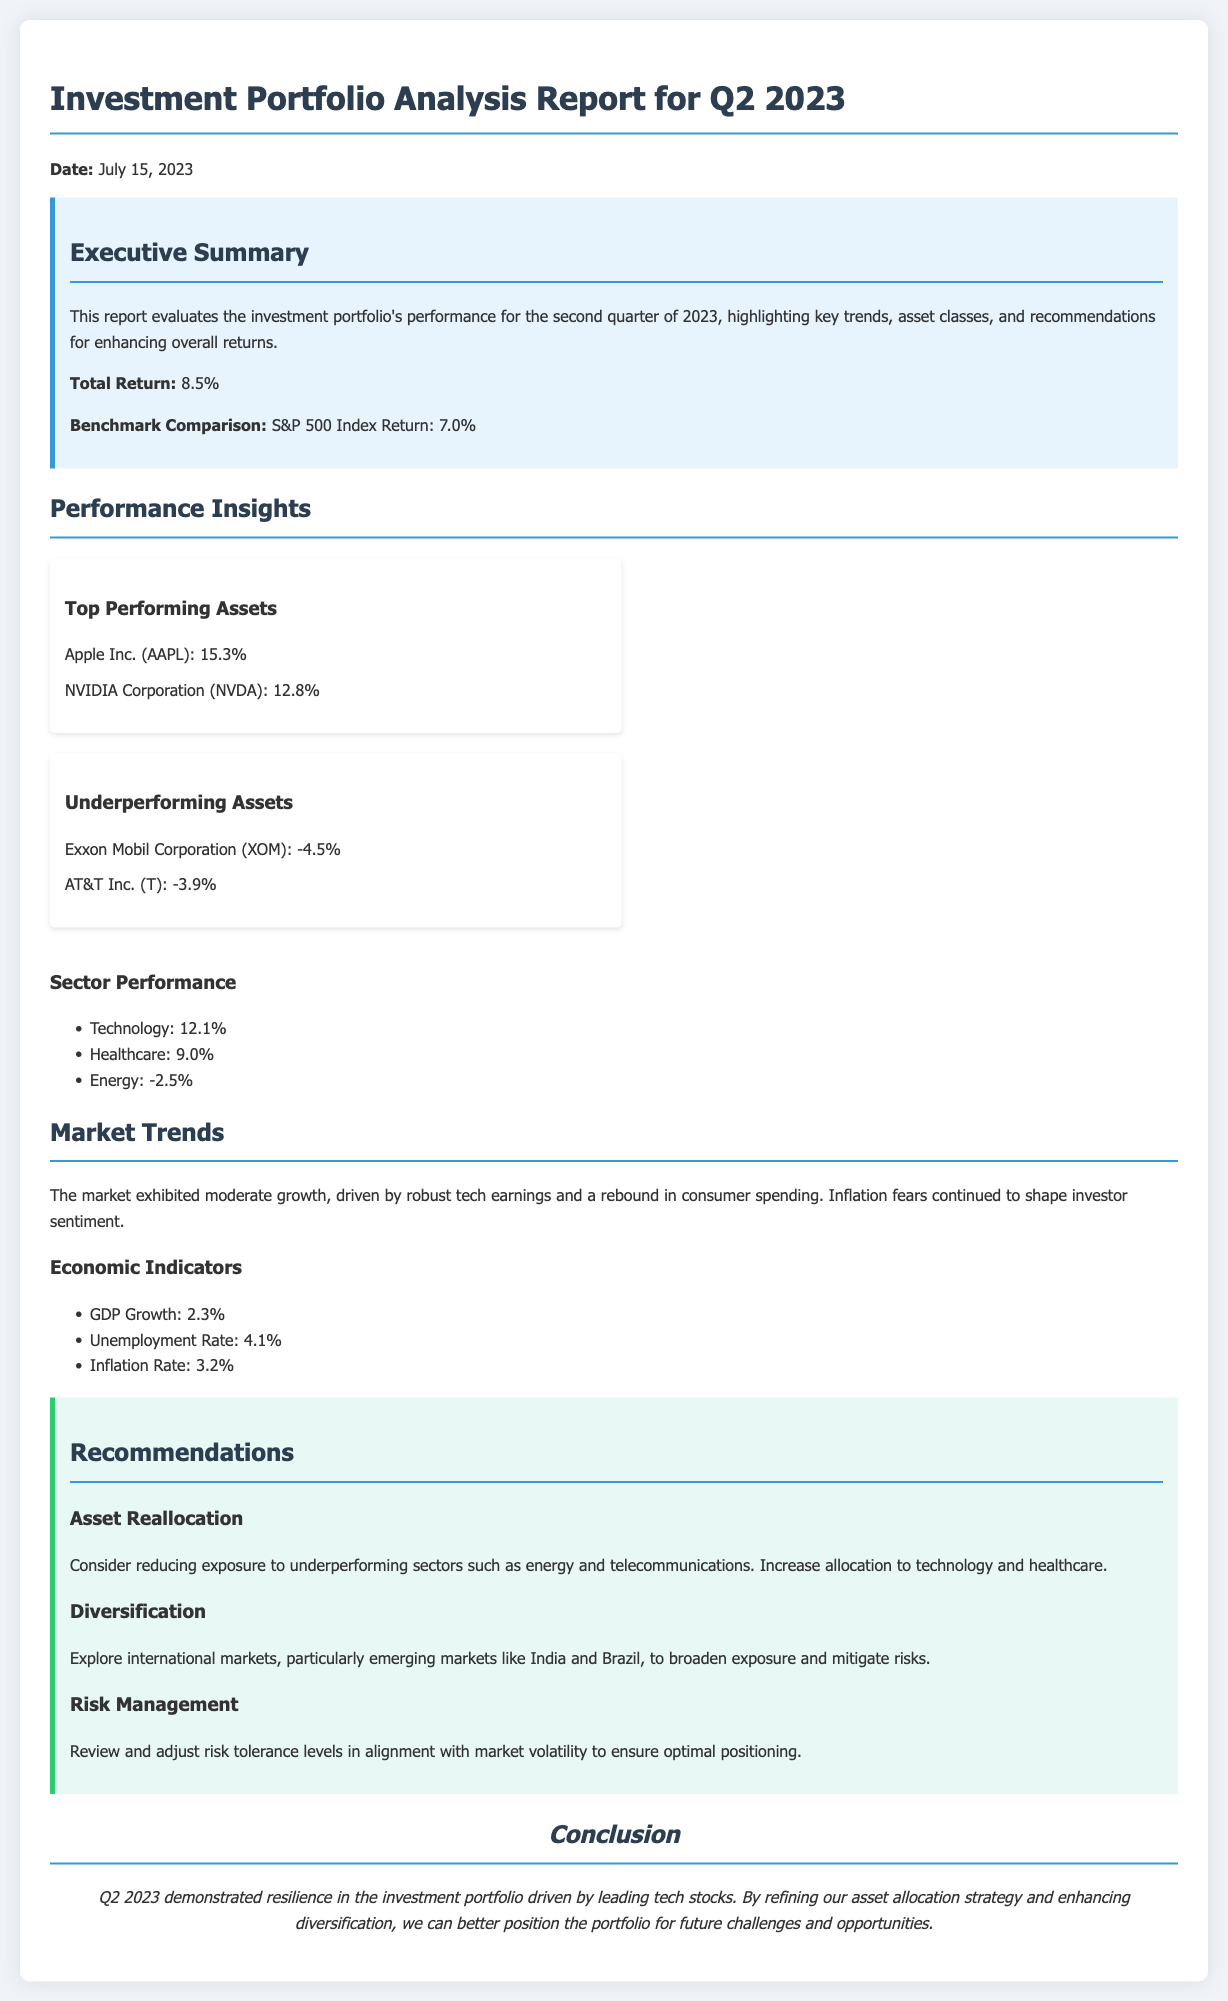What is the total return for Q2 2023? The total return for Q2 2023 is provided in the executive summary section, highlighting the portfolio’s performance.
Answer: 8.5% What is the S&P 500 index return for the same period? The document compares the portfolio's return to the benchmark in the executive summary.
Answer: 7.0% Which asset had the highest return? The document lists the top performing assets in the performance insights section, indicating their performance percentages.
Answer: Apple Inc. (AAPL): 15.3% What are the underperforming assets listed? The underperforming assets are provided in a separate section, noting their performance.
Answer: Exxon Mobil Corporation (XOM) and AT&T Inc. (T) What sector had the best performance? The performance insights include a list of sector performances, indicating which one outperformed others.
Answer: Technology: 12.1% What is the GDP growth rate mentioned in the report? GDP growth is an economic indicator included in the market trends section of the report.
Answer: 2.3% What risk management strategy is recommended? The recommendations section advises on reviewing and adjusting risk tolerance levels.
Answer: Review and adjust risk tolerance levels What is one suggested area for diversification? The recommendations mention exploring international markets, which indicates areas for further investment.
Answer: Emerging markets like India and Brazil What date was the report finalized? The report states the date of its publication in the introductory section, which is key for context.
Answer: July 15, 2023 